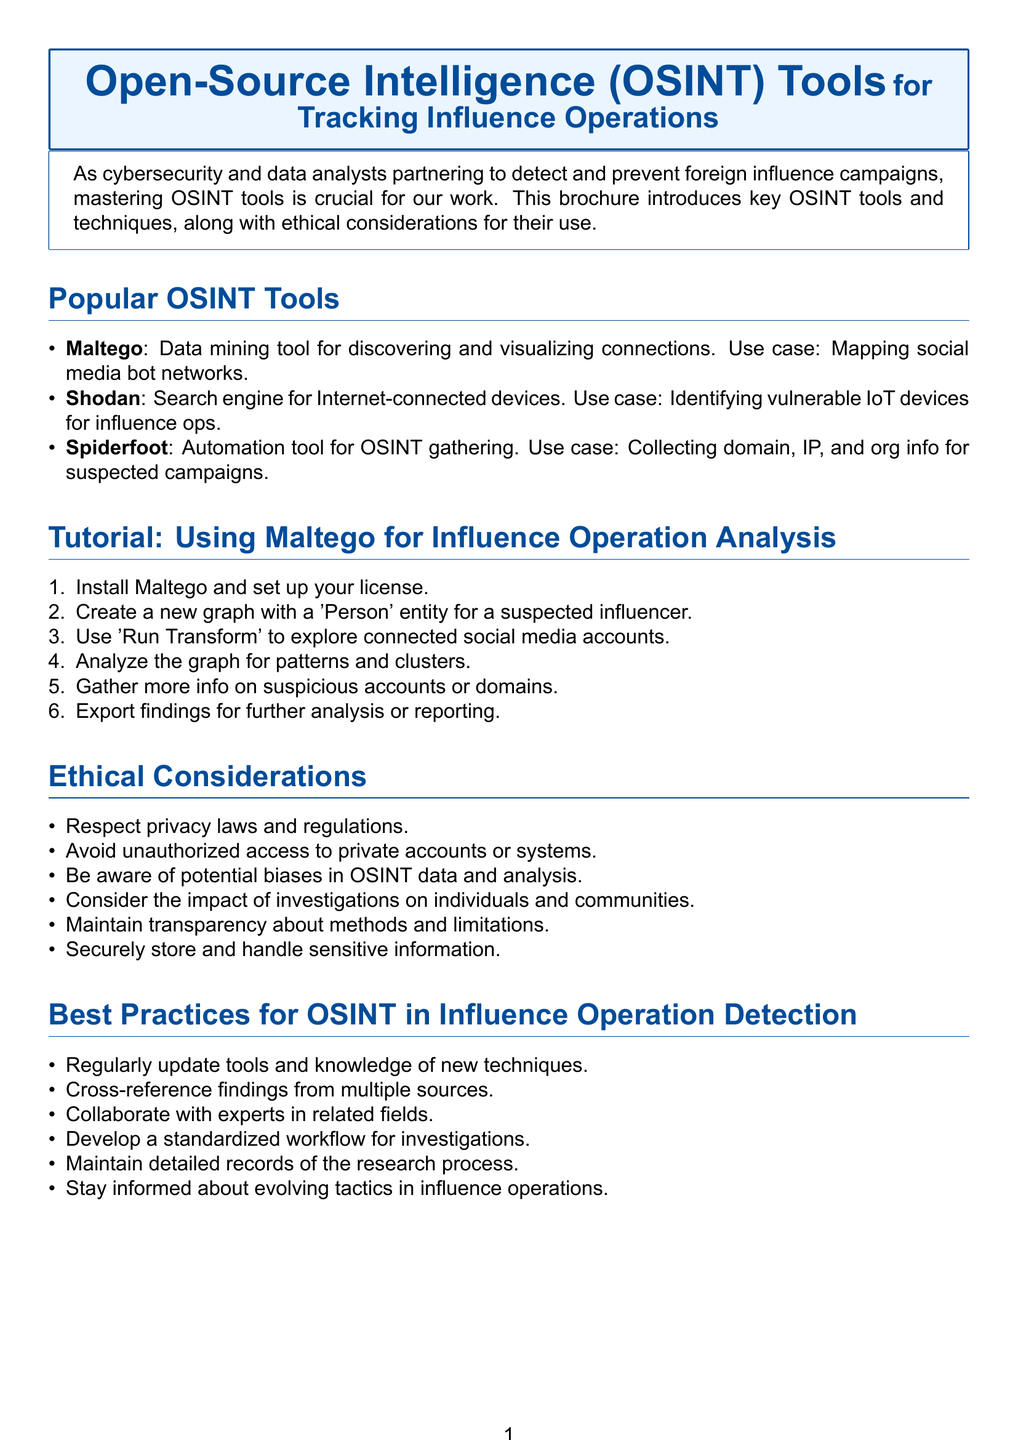What is the title of the brochure? The title is introduced at the top of the document and specifies the focus on OSINT tools for tracking influence operations.
Answer: Open-Source Intelligence (OSINT) Tools for Tracking Influence Operations How many popular OSINT tools are listed? The content describes three popular OSINT tools listed in that section.
Answer: Three What is the first step in the Maltego tutorial? The tutorial section outlines the steps sequentially, starting with the installation process.
Answer: Install Maltego and set up your free or commercial license What should you avoid according to ethical considerations? Ethical considerations point out potential actions that should be avoided, including unauthorized access.
Answer: Unauthorized access to private accounts or protected systems What was the outcome of the case study? The case study concludes with the reporting of findings and actions taken based on them.
Answer: Findings reported to social media platforms and relevant authorities, leading to account takedowns and public awareness campaign Which tools were used in the case study? The case study specifies the tools that contributed to uncovering a disinformation network.
Answer: Maltego, Spiderfoot, Twitter API What is suggested for improving OSINT accuracy? Best practices for OSINT suggest methods to ensure precision in findings.
Answer: Cross-reference findings from multiple sources to improve accuracy How many key findings were reported in the case study? Key findings are listed in a bullet format in the case study, with three specific items mentioned.
Answer: Three 